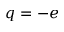Convert formula to latex. <formula><loc_0><loc_0><loc_500><loc_500>q = - e</formula> 